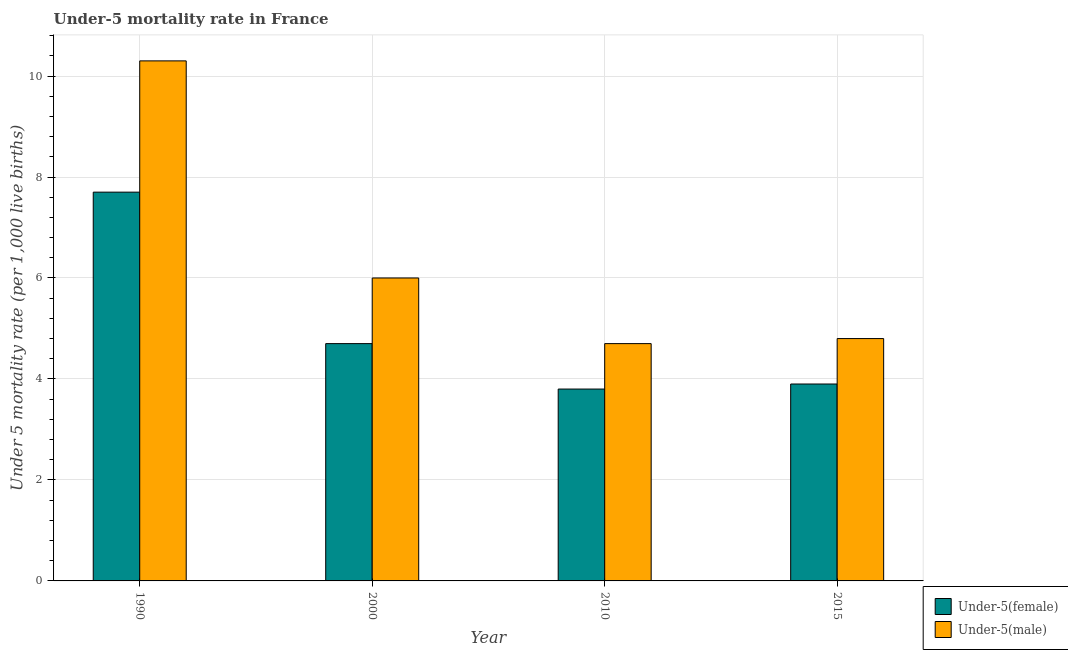How many groups of bars are there?
Make the answer very short. 4. Are the number of bars on each tick of the X-axis equal?
Keep it short and to the point. Yes. Across all years, what is the minimum under-5 female mortality rate?
Your answer should be compact. 3.8. In which year was the under-5 male mortality rate minimum?
Your response must be concise. 2010. What is the total under-5 male mortality rate in the graph?
Your response must be concise. 25.8. What is the difference between the under-5 female mortality rate in 2010 and that in 2015?
Provide a short and direct response. -0.1. What is the difference between the under-5 male mortality rate in 2015 and the under-5 female mortality rate in 1990?
Your response must be concise. -5.5. What is the average under-5 female mortality rate per year?
Your answer should be very brief. 5.02. What is the ratio of the under-5 female mortality rate in 1990 to that in 2010?
Make the answer very short. 2.03. What is the difference between the highest and the second highest under-5 female mortality rate?
Provide a succinct answer. 3. What is the difference between the highest and the lowest under-5 male mortality rate?
Make the answer very short. 5.6. In how many years, is the under-5 female mortality rate greater than the average under-5 female mortality rate taken over all years?
Keep it short and to the point. 1. Is the sum of the under-5 male mortality rate in 2000 and 2015 greater than the maximum under-5 female mortality rate across all years?
Your answer should be very brief. Yes. What does the 1st bar from the left in 2015 represents?
Provide a short and direct response. Under-5(female). What does the 1st bar from the right in 1990 represents?
Your answer should be compact. Under-5(male). How many bars are there?
Your answer should be very brief. 8. Are the values on the major ticks of Y-axis written in scientific E-notation?
Your response must be concise. No. Does the graph contain grids?
Your response must be concise. Yes. Where does the legend appear in the graph?
Your answer should be compact. Bottom right. How many legend labels are there?
Your answer should be compact. 2. What is the title of the graph?
Your response must be concise. Under-5 mortality rate in France. Does "Official creditors" appear as one of the legend labels in the graph?
Your response must be concise. No. What is the label or title of the X-axis?
Make the answer very short. Year. What is the label or title of the Y-axis?
Give a very brief answer. Under 5 mortality rate (per 1,0 live births). What is the Under 5 mortality rate (per 1,000 live births) in Under-5(female) in 1990?
Your response must be concise. 7.7. What is the Under 5 mortality rate (per 1,000 live births) of Under-5(female) in 2000?
Your answer should be compact. 4.7. What is the Under 5 mortality rate (per 1,000 live births) in Under-5(male) in 2000?
Make the answer very short. 6. What is the Under 5 mortality rate (per 1,000 live births) in Under-5(male) in 2010?
Your response must be concise. 4.7. Across all years, what is the maximum Under 5 mortality rate (per 1,000 live births) in Under-5(female)?
Your answer should be very brief. 7.7. Across all years, what is the minimum Under 5 mortality rate (per 1,000 live births) of Under-5(female)?
Offer a terse response. 3.8. What is the total Under 5 mortality rate (per 1,000 live births) in Under-5(female) in the graph?
Your answer should be very brief. 20.1. What is the total Under 5 mortality rate (per 1,000 live births) of Under-5(male) in the graph?
Ensure brevity in your answer.  25.8. What is the difference between the Under 5 mortality rate (per 1,000 live births) in Under-5(female) in 1990 and that in 2000?
Your answer should be compact. 3. What is the difference between the Under 5 mortality rate (per 1,000 live births) in Under-5(male) in 1990 and that in 2000?
Keep it short and to the point. 4.3. What is the difference between the Under 5 mortality rate (per 1,000 live births) in Under-5(female) in 1990 and that in 2010?
Give a very brief answer. 3.9. What is the difference between the Under 5 mortality rate (per 1,000 live births) in Under-5(female) in 1990 and that in 2015?
Offer a terse response. 3.8. What is the difference between the Under 5 mortality rate (per 1,000 live births) of Under-5(female) in 2000 and that in 2010?
Your response must be concise. 0.9. What is the difference between the Under 5 mortality rate (per 1,000 live births) in Under-5(male) in 2000 and that in 2010?
Give a very brief answer. 1.3. What is the difference between the Under 5 mortality rate (per 1,000 live births) of Under-5(female) in 2010 and that in 2015?
Give a very brief answer. -0.1. What is the difference between the Under 5 mortality rate (per 1,000 live births) in Under-5(female) in 2000 and the Under 5 mortality rate (per 1,000 live births) in Under-5(male) in 2010?
Keep it short and to the point. 0. What is the difference between the Under 5 mortality rate (per 1,000 live births) in Under-5(female) in 2010 and the Under 5 mortality rate (per 1,000 live births) in Under-5(male) in 2015?
Make the answer very short. -1. What is the average Under 5 mortality rate (per 1,000 live births) of Under-5(female) per year?
Offer a very short reply. 5.03. What is the average Under 5 mortality rate (per 1,000 live births) of Under-5(male) per year?
Keep it short and to the point. 6.45. In the year 2015, what is the difference between the Under 5 mortality rate (per 1,000 live births) of Under-5(female) and Under 5 mortality rate (per 1,000 live births) of Under-5(male)?
Make the answer very short. -0.9. What is the ratio of the Under 5 mortality rate (per 1,000 live births) in Under-5(female) in 1990 to that in 2000?
Offer a terse response. 1.64. What is the ratio of the Under 5 mortality rate (per 1,000 live births) of Under-5(male) in 1990 to that in 2000?
Provide a short and direct response. 1.72. What is the ratio of the Under 5 mortality rate (per 1,000 live births) in Under-5(female) in 1990 to that in 2010?
Ensure brevity in your answer.  2.03. What is the ratio of the Under 5 mortality rate (per 1,000 live births) in Under-5(male) in 1990 to that in 2010?
Your answer should be very brief. 2.19. What is the ratio of the Under 5 mortality rate (per 1,000 live births) of Under-5(female) in 1990 to that in 2015?
Offer a very short reply. 1.97. What is the ratio of the Under 5 mortality rate (per 1,000 live births) in Under-5(male) in 1990 to that in 2015?
Offer a very short reply. 2.15. What is the ratio of the Under 5 mortality rate (per 1,000 live births) in Under-5(female) in 2000 to that in 2010?
Make the answer very short. 1.24. What is the ratio of the Under 5 mortality rate (per 1,000 live births) in Under-5(male) in 2000 to that in 2010?
Give a very brief answer. 1.28. What is the ratio of the Under 5 mortality rate (per 1,000 live births) of Under-5(female) in 2000 to that in 2015?
Your answer should be compact. 1.21. What is the ratio of the Under 5 mortality rate (per 1,000 live births) of Under-5(male) in 2000 to that in 2015?
Give a very brief answer. 1.25. What is the ratio of the Under 5 mortality rate (per 1,000 live births) of Under-5(female) in 2010 to that in 2015?
Make the answer very short. 0.97. What is the ratio of the Under 5 mortality rate (per 1,000 live births) in Under-5(male) in 2010 to that in 2015?
Provide a succinct answer. 0.98. 